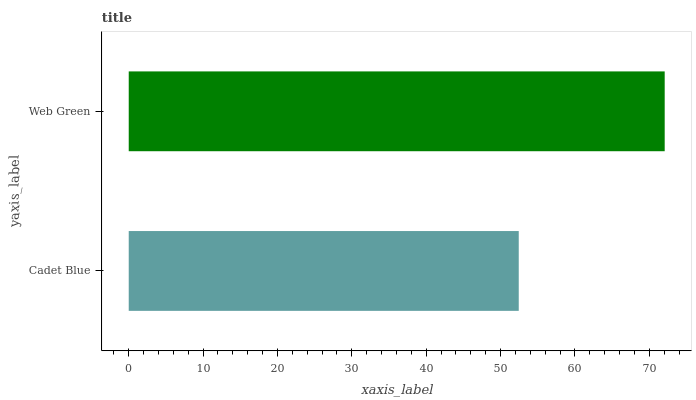Is Cadet Blue the minimum?
Answer yes or no. Yes. Is Web Green the maximum?
Answer yes or no. Yes. Is Web Green the minimum?
Answer yes or no. No. Is Web Green greater than Cadet Blue?
Answer yes or no. Yes. Is Cadet Blue less than Web Green?
Answer yes or no. Yes. Is Cadet Blue greater than Web Green?
Answer yes or no. No. Is Web Green less than Cadet Blue?
Answer yes or no. No. Is Web Green the high median?
Answer yes or no. Yes. Is Cadet Blue the low median?
Answer yes or no. Yes. Is Cadet Blue the high median?
Answer yes or no. No. Is Web Green the low median?
Answer yes or no. No. 